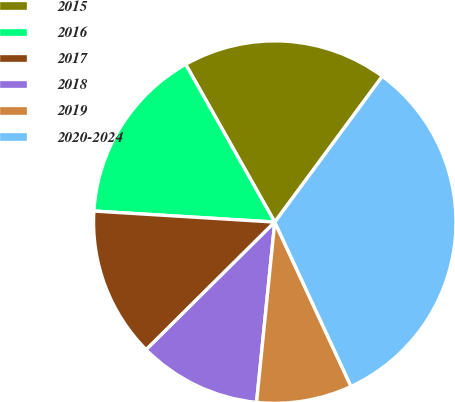Convert chart. <chart><loc_0><loc_0><loc_500><loc_500><pie_chart><fcel>2015<fcel>2016<fcel>2017<fcel>2018<fcel>2019<fcel>2020-2024<nl><fcel>18.3%<fcel>15.85%<fcel>13.41%<fcel>10.96%<fcel>8.52%<fcel>32.97%<nl></chart> 